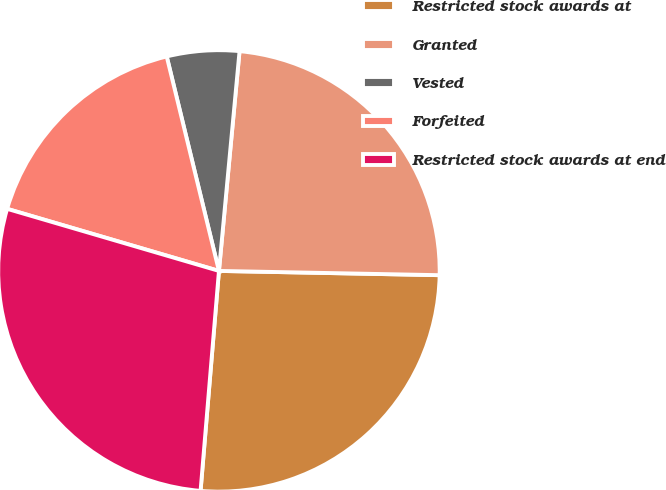<chart> <loc_0><loc_0><loc_500><loc_500><pie_chart><fcel>Restricted stock awards at<fcel>Granted<fcel>Vested<fcel>Forfeited<fcel>Restricted stock awards at end<nl><fcel>26.02%<fcel>23.82%<fcel>5.29%<fcel>16.66%<fcel>28.21%<nl></chart> 